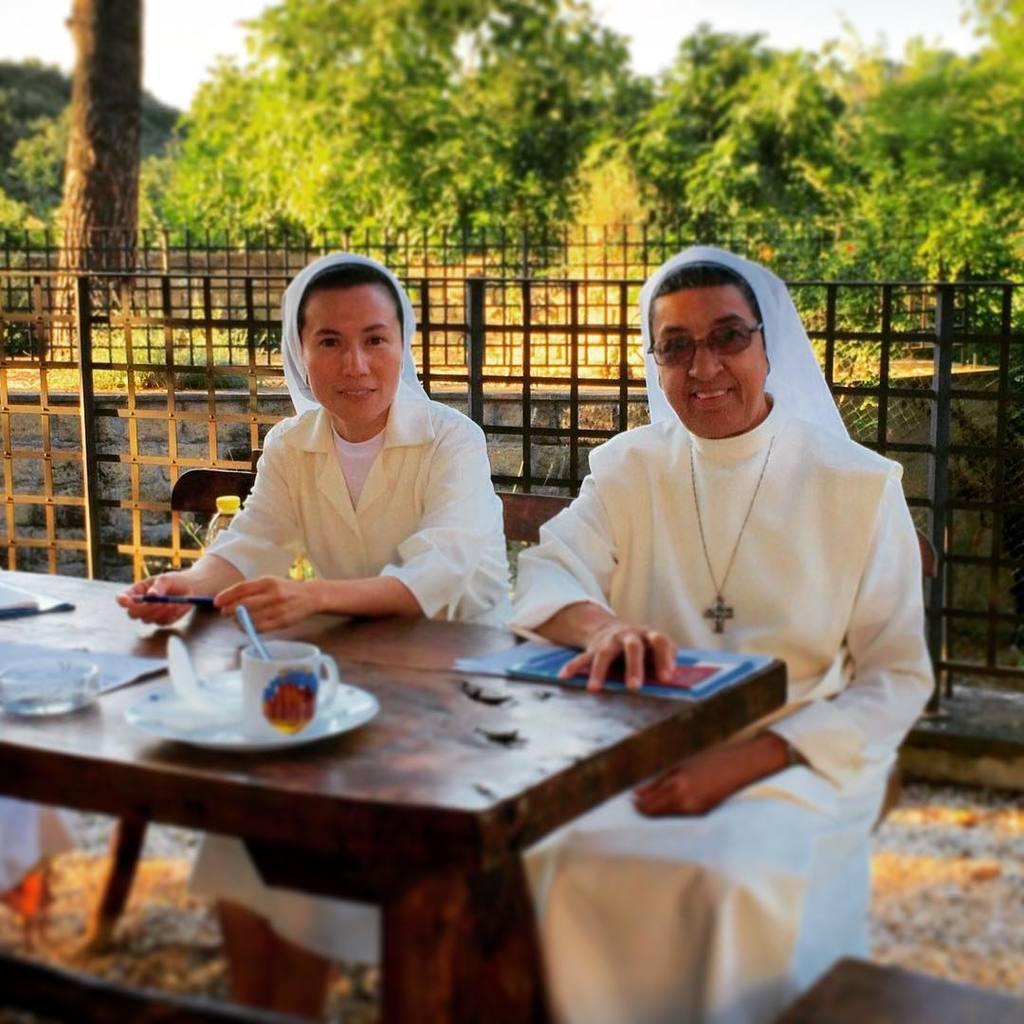In one or two sentences, can you explain what this image depicts? There are two women sitting on a bench. They were dressed in white color. This is a table with a plate,mug,paper,books and some object on it. This is a wooden fencing at background I can see a trees and plants. 